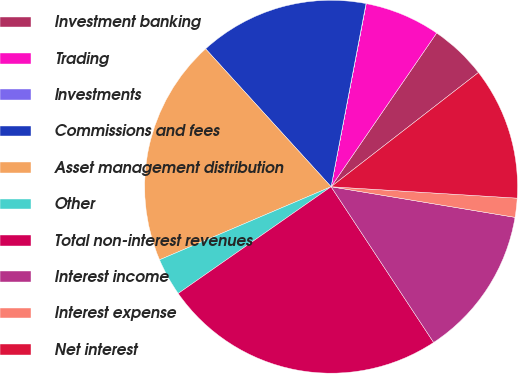<chart> <loc_0><loc_0><loc_500><loc_500><pie_chart><fcel>Investment banking<fcel>Trading<fcel>Investments<fcel>Commissions and fees<fcel>Asset management distribution<fcel>Other<fcel>Total non-interest revenues<fcel>Interest income<fcel>Interest expense<fcel>Net interest<nl><fcel>4.93%<fcel>6.56%<fcel>0.02%<fcel>14.75%<fcel>19.66%<fcel>3.29%<fcel>24.57%<fcel>13.11%<fcel>1.65%<fcel>11.47%<nl></chart> 